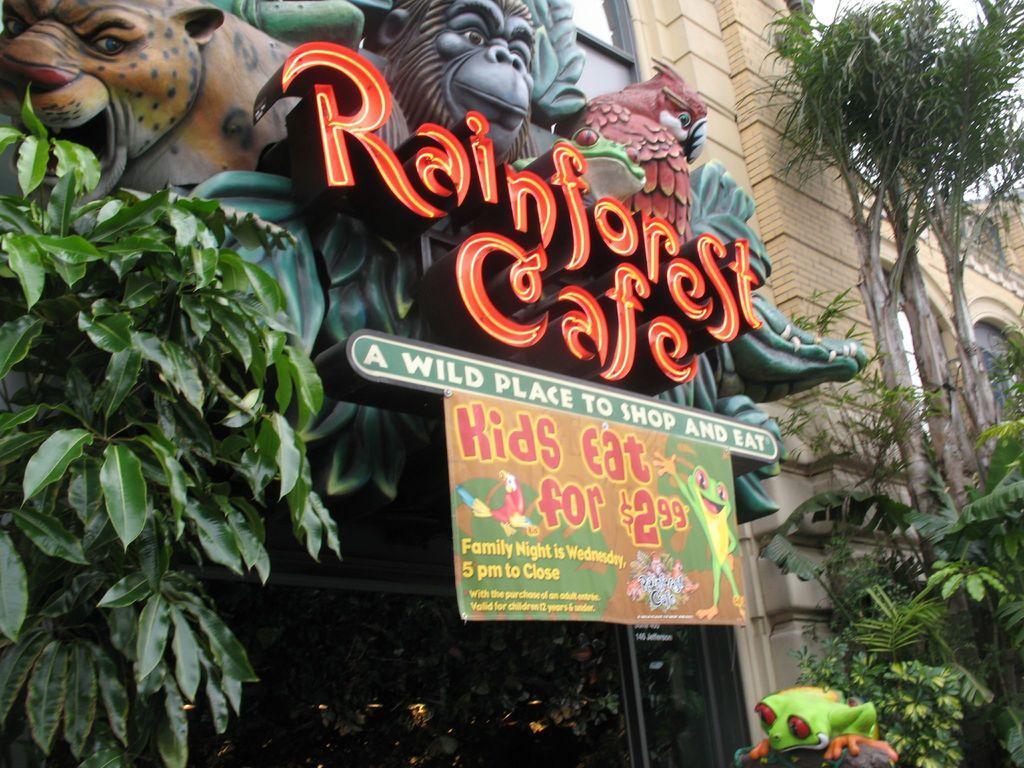Describe this image in one or two sentences. In this image we can see the entrance of a rain forest with some animal structures and a label, on the either side of the label there are trees. 